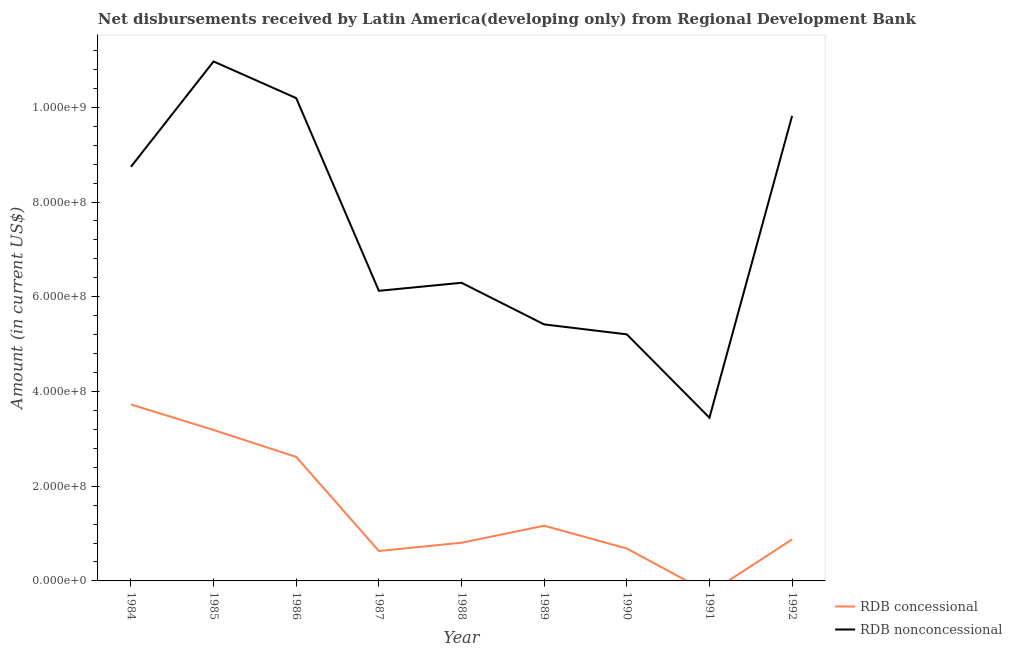Is the number of lines equal to the number of legend labels?
Offer a very short reply. No. Across all years, what is the maximum net non concessional disbursements from rdb?
Your answer should be very brief. 1.10e+09. What is the total net concessional disbursements from rdb in the graph?
Provide a succinct answer. 1.37e+09. What is the difference between the net concessional disbursements from rdb in 1985 and that in 1988?
Offer a very short reply. 2.38e+08. What is the difference between the net concessional disbursements from rdb in 1989 and the net non concessional disbursements from rdb in 1988?
Give a very brief answer. -5.13e+08. What is the average net non concessional disbursements from rdb per year?
Keep it short and to the point. 7.36e+08. In the year 1984, what is the difference between the net non concessional disbursements from rdb and net concessional disbursements from rdb?
Your response must be concise. 5.02e+08. In how many years, is the net concessional disbursements from rdb greater than 400000000 US$?
Your answer should be compact. 0. What is the ratio of the net concessional disbursements from rdb in 1987 to that in 1990?
Keep it short and to the point. 0.92. Is the net concessional disbursements from rdb in 1985 less than that in 1987?
Give a very brief answer. No. Is the difference between the net non concessional disbursements from rdb in 1988 and 1992 greater than the difference between the net concessional disbursements from rdb in 1988 and 1992?
Provide a succinct answer. No. What is the difference between the highest and the second highest net non concessional disbursements from rdb?
Make the answer very short. 7.74e+07. What is the difference between the highest and the lowest net concessional disbursements from rdb?
Ensure brevity in your answer.  3.73e+08. Is the net non concessional disbursements from rdb strictly less than the net concessional disbursements from rdb over the years?
Make the answer very short. No. What is the difference between two consecutive major ticks on the Y-axis?
Your answer should be compact. 2.00e+08. Does the graph contain any zero values?
Provide a succinct answer. Yes. Does the graph contain grids?
Make the answer very short. No. Where does the legend appear in the graph?
Provide a succinct answer. Bottom right. What is the title of the graph?
Your answer should be compact. Net disbursements received by Latin America(developing only) from Regional Development Bank. Does "Import" appear as one of the legend labels in the graph?
Your answer should be compact. No. What is the label or title of the X-axis?
Your answer should be very brief. Year. What is the Amount (in current US$) of RDB concessional in 1984?
Ensure brevity in your answer.  3.73e+08. What is the Amount (in current US$) of RDB nonconcessional in 1984?
Your answer should be compact. 8.74e+08. What is the Amount (in current US$) in RDB concessional in 1985?
Ensure brevity in your answer.  3.19e+08. What is the Amount (in current US$) of RDB nonconcessional in 1985?
Provide a short and direct response. 1.10e+09. What is the Amount (in current US$) of RDB concessional in 1986?
Give a very brief answer. 2.62e+08. What is the Amount (in current US$) in RDB nonconcessional in 1986?
Make the answer very short. 1.02e+09. What is the Amount (in current US$) in RDB concessional in 1987?
Make the answer very short. 6.32e+07. What is the Amount (in current US$) in RDB nonconcessional in 1987?
Offer a very short reply. 6.13e+08. What is the Amount (in current US$) of RDB concessional in 1988?
Your answer should be very brief. 8.06e+07. What is the Amount (in current US$) in RDB nonconcessional in 1988?
Offer a terse response. 6.30e+08. What is the Amount (in current US$) in RDB concessional in 1989?
Your answer should be very brief. 1.17e+08. What is the Amount (in current US$) in RDB nonconcessional in 1989?
Keep it short and to the point. 5.42e+08. What is the Amount (in current US$) of RDB concessional in 1990?
Keep it short and to the point. 6.85e+07. What is the Amount (in current US$) in RDB nonconcessional in 1990?
Make the answer very short. 5.21e+08. What is the Amount (in current US$) of RDB concessional in 1991?
Keep it short and to the point. 0. What is the Amount (in current US$) of RDB nonconcessional in 1991?
Your response must be concise. 3.45e+08. What is the Amount (in current US$) in RDB concessional in 1992?
Give a very brief answer. 8.76e+07. What is the Amount (in current US$) of RDB nonconcessional in 1992?
Your response must be concise. 9.82e+08. Across all years, what is the maximum Amount (in current US$) of RDB concessional?
Your answer should be compact. 3.73e+08. Across all years, what is the maximum Amount (in current US$) of RDB nonconcessional?
Provide a succinct answer. 1.10e+09. Across all years, what is the minimum Amount (in current US$) of RDB nonconcessional?
Ensure brevity in your answer.  3.45e+08. What is the total Amount (in current US$) of RDB concessional in the graph?
Offer a terse response. 1.37e+09. What is the total Amount (in current US$) in RDB nonconcessional in the graph?
Offer a very short reply. 6.62e+09. What is the difference between the Amount (in current US$) in RDB concessional in 1984 and that in 1985?
Make the answer very short. 5.39e+07. What is the difference between the Amount (in current US$) in RDB nonconcessional in 1984 and that in 1985?
Your response must be concise. -2.22e+08. What is the difference between the Amount (in current US$) of RDB concessional in 1984 and that in 1986?
Provide a succinct answer. 1.11e+08. What is the difference between the Amount (in current US$) in RDB nonconcessional in 1984 and that in 1986?
Keep it short and to the point. -1.45e+08. What is the difference between the Amount (in current US$) of RDB concessional in 1984 and that in 1987?
Keep it short and to the point. 3.09e+08. What is the difference between the Amount (in current US$) in RDB nonconcessional in 1984 and that in 1987?
Offer a terse response. 2.62e+08. What is the difference between the Amount (in current US$) in RDB concessional in 1984 and that in 1988?
Provide a succinct answer. 2.92e+08. What is the difference between the Amount (in current US$) in RDB nonconcessional in 1984 and that in 1988?
Give a very brief answer. 2.45e+08. What is the difference between the Amount (in current US$) in RDB concessional in 1984 and that in 1989?
Your answer should be very brief. 2.56e+08. What is the difference between the Amount (in current US$) of RDB nonconcessional in 1984 and that in 1989?
Offer a terse response. 3.33e+08. What is the difference between the Amount (in current US$) in RDB concessional in 1984 and that in 1990?
Offer a very short reply. 3.04e+08. What is the difference between the Amount (in current US$) in RDB nonconcessional in 1984 and that in 1990?
Ensure brevity in your answer.  3.54e+08. What is the difference between the Amount (in current US$) of RDB nonconcessional in 1984 and that in 1991?
Make the answer very short. 5.30e+08. What is the difference between the Amount (in current US$) of RDB concessional in 1984 and that in 1992?
Ensure brevity in your answer.  2.85e+08. What is the difference between the Amount (in current US$) of RDB nonconcessional in 1984 and that in 1992?
Provide a short and direct response. -1.08e+08. What is the difference between the Amount (in current US$) in RDB concessional in 1985 and that in 1986?
Make the answer very short. 5.69e+07. What is the difference between the Amount (in current US$) of RDB nonconcessional in 1985 and that in 1986?
Give a very brief answer. 7.74e+07. What is the difference between the Amount (in current US$) in RDB concessional in 1985 and that in 1987?
Provide a succinct answer. 2.56e+08. What is the difference between the Amount (in current US$) of RDB nonconcessional in 1985 and that in 1987?
Your response must be concise. 4.84e+08. What is the difference between the Amount (in current US$) of RDB concessional in 1985 and that in 1988?
Keep it short and to the point. 2.38e+08. What is the difference between the Amount (in current US$) in RDB nonconcessional in 1985 and that in 1988?
Make the answer very short. 4.67e+08. What is the difference between the Amount (in current US$) of RDB concessional in 1985 and that in 1989?
Offer a very short reply. 2.02e+08. What is the difference between the Amount (in current US$) in RDB nonconcessional in 1985 and that in 1989?
Provide a succinct answer. 5.55e+08. What is the difference between the Amount (in current US$) in RDB concessional in 1985 and that in 1990?
Offer a very short reply. 2.50e+08. What is the difference between the Amount (in current US$) of RDB nonconcessional in 1985 and that in 1990?
Ensure brevity in your answer.  5.76e+08. What is the difference between the Amount (in current US$) of RDB nonconcessional in 1985 and that in 1991?
Keep it short and to the point. 7.52e+08. What is the difference between the Amount (in current US$) of RDB concessional in 1985 and that in 1992?
Your answer should be very brief. 2.31e+08. What is the difference between the Amount (in current US$) of RDB nonconcessional in 1985 and that in 1992?
Ensure brevity in your answer.  1.15e+08. What is the difference between the Amount (in current US$) in RDB concessional in 1986 and that in 1987?
Provide a succinct answer. 1.99e+08. What is the difference between the Amount (in current US$) in RDB nonconcessional in 1986 and that in 1987?
Make the answer very short. 4.07e+08. What is the difference between the Amount (in current US$) of RDB concessional in 1986 and that in 1988?
Your answer should be compact. 1.81e+08. What is the difference between the Amount (in current US$) of RDB nonconcessional in 1986 and that in 1988?
Give a very brief answer. 3.90e+08. What is the difference between the Amount (in current US$) of RDB concessional in 1986 and that in 1989?
Your answer should be compact. 1.45e+08. What is the difference between the Amount (in current US$) of RDB nonconcessional in 1986 and that in 1989?
Provide a short and direct response. 4.78e+08. What is the difference between the Amount (in current US$) of RDB concessional in 1986 and that in 1990?
Provide a succinct answer. 1.93e+08. What is the difference between the Amount (in current US$) in RDB nonconcessional in 1986 and that in 1990?
Provide a short and direct response. 4.99e+08. What is the difference between the Amount (in current US$) in RDB nonconcessional in 1986 and that in 1991?
Provide a short and direct response. 6.75e+08. What is the difference between the Amount (in current US$) of RDB concessional in 1986 and that in 1992?
Offer a very short reply. 1.74e+08. What is the difference between the Amount (in current US$) in RDB nonconcessional in 1986 and that in 1992?
Provide a succinct answer. 3.75e+07. What is the difference between the Amount (in current US$) in RDB concessional in 1987 and that in 1988?
Your answer should be compact. -1.74e+07. What is the difference between the Amount (in current US$) of RDB nonconcessional in 1987 and that in 1988?
Your answer should be very brief. -1.70e+07. What is the difference between the Amount (in current US$) in RDB concessional in 1987 and that in 1989?
Ensure brevity in your answer.  -5.33e+07. What is the difference between the Amount (in current US$) in RDB nonconcessional in 1987 and that in 1989?
Your answer should be very brief. 7.09e+07. What is the difference between the Amount (in current US$) of RDB concessional in 1987 and that in 1990?
Offer a terse response. -5.23e+06. What is the difference between the Amount (in current US$) of RDB nonconcessional in 1987 and that in 1990?
Provide a succinct answer. 9.19e+07. What is the difference between the Amount (in current US$) in RDB nonconcessional in 1987 and that in 1991?
Ensure brevity in your answer.  2.68e+08. What is the difference between the Amount (in current US$) in RDB concessional in 1987 and that in 1992?
Give a very brief answer. -2.44e+07. What is the difference between the Amount (in current US$) in RDB nonconcessional in 1987 and that in 1992?
Make the answer very short. -3.69e+08. What is the difference between the Amount (in current US$) of RDB concessional in 1988 and that in 1989?
Give a very brief answer. -3.59e+07. What is the difference between the Amount (in current US$) of RDB nonconcessional in 1988 and that in 1989?
Your response must be concise. 8.79e+07. What is the difference between the Amount (in current US$) of RDB concessional in 1988 and that in 1990?
Provide a succinct answer. 1.22e+07. What is the difference between the Amount (in current US$) in RDB nonconcessional in 1988 and that in 1990?
Give a very brief answer. 1.09e+08. What is the difference between the Amount (in current US$) in RDB nonconcessional in 1988 and that in 1991?
Offer a very short reply. 2.85e+08. What is the difference between the Amount (in current US$) in RDB concessional in 1988 and that in 1992?
Provide a succinct answer. -7.02e+06. What is the difference between the Amount (in current US$) in RDB nonconcessional in 1988 and that in 1992?
Provide a short and direct response. -3.52e+08. What is the difference between the Amount (in current US$) of RDB concessional in 1989 and that in 1990?
Provide a short and direct response. 4.81e+07. What is the difference between the Amount (in current US$) in RDB nonconcessional in 1989 and that in 1990?
Provide a short and direct response. 2.10e+07. What is the difference between the Amount (in current US$) in RDB nonconcessional in 1989 and that in 1991?
Make the answer very short. 1.97e+08. What is the difference between the Amount (in current US$) of RDB concessional in 1989 and that in 1992?
Provide a succinct answer. 2.89e+07. What is the difference between the Amount (in current US$) of RDB nonconcessional in 1989 and that in 1992?
Provide a short and direct response. -4.40e+08. What is the difference between the Amount (in current US$) in RDB nonconcessional in 1990 and that in 1991?
Your answer should be very brief. 1.76e+08. What is the difference between the Amount (in current US$) of RDB concessional in 1990 and that in 1992?
Keep it short and to the point. -1.92e+07. What is the difference between the Amount (in current US$) in RDB nonconcessional in 1990 and that in 1992?
Provide a short and direct response. -4.61e+08. What is the difference between the Amount (in current US$) of RDB nonconcessional in 1991 and that in 1992?
Your answer should be very brief. -6.37e+08. What is the difference between the Amount (in current US$) of RDB concessional in 1984 and the Amount (in current US$) of RDB nonconcessional in 1985?
Keep it short and to the point. -7.24e+08. What is the difference between the Amount (in current US$) in RDB concessional in 1984 and the Amount (in current US$) in RDB nonconcessional in 1986?
Provide a short and direct response. -6.47e+08. What is the difference between the Amount (in current US$) of RDB concessional in 1984 and the Amount (in current US$) of RDB nonconcessional in 1987?
Provide a short and direct response. -2.40e+08. What is the difference between the Amount (in current US$) in RDB concessional in 1984 and the Amount (in current US$) in RDB nonconcessional in 1988?
Give a very brief answer. -2.57e+08. What is the difference between the Amount (in current US$) in RDB concessional in 1984 and the Amount (in current US$) in RDB nonconcessional in 1989?
Keep it short and to the point. -1.69e+08. What is the difference between the Amount (in current US$) in RDB concessional in 1984 and the Amount (in current US$) in RDB nonconcessional in 1990?
Offer a terse response. -1.48e+08. What is the difference between the Amount (in current US$) in RDB concessional in 1984 and the Amount (in current US$) in RDB nonconcessional in 1991?
Ensure brevity in your answer.  2.80e+07. What is the difference between the Amount (in current US$) of RDB concessional in 1984 and the Amount (in current US$) of RDB nonconcessional in 1992?
Provide a short and direct response. -6.09e+08. What is the difference between the Amount (in current US$) of RDB concessional in 1985 and the Amount (in current US$) of RDB nonconcessional in 1986?
Provide a succinct answer. -7.01e+08. What is the difference between the Amount (in current US$) of RDB concessional in 1985 and the Amount (in current US$) of RDB nonconcessional in 1987?
Give a very brief answer. -2.94e+08. What is the difference between the Amount (in current US$) of RDB concessional in 1985 and the Amount (in current US$) of RDB nonconcessional in 1988?
Give a very brief answer. -3.11e+08. What is the difference between the Amount (in current US$) of RDB concessional in 1985 and the Amount (in current US$) of RDB nonconcessional in 1989?
Offer a very short reply. -2.23e+08. What is the difference between the Amount (in current US$) in RDB concessional in 1985 and the Amount (in current US$) in RDB nonconcessional in 1990?
Keep it short and to the point. -2.02e+08. What is the difference between the Amount (in current US$) of RDB concessional in 1985 and the Amount (in current US$) of RDB nonconcessional in 1991?
Offer a terse response. -2.59e+07. What is the difference between the Amount (in current US$) in RDB concessional in 1985 and the Amount (in current US$) in RDB nonconcessional in 1992?
Offer a terse response. -6.63e+08. What is the difference between the Amount (in current US$) of RDB concessional in 1986 and the Amount (in current US$) of RDB nonconcessional in 1987?
Offer a terse response. -3.51e+08. What is the difference between the Amount (in current US$) in RDB concessional in 1986 and the Amount (in current US$) in RDB nonconcessional in 1988?
Make the answer very short. -3.68e+08. What is the difference between the Amount (in current US$) of RDB concessional in 1986 and the Amount (in current US$) of RDB nonconcessional in 1989?
Your answer should be very brief. -2.80e+08. What is the difference between the Amount (in current US$) of RDB concessional in 1986 and the Amount (in current US$) of RDB nonconcessional in 1990?
Make the answer very short. -2.59e+08. What is the difference between the Amount (in current US$) of RDB concessional in 1986 and the Amount (in current US$) of RDB nonconcessional in 1991?
Offer a terse response. -8.29e+07. What is the difference between the Amount (in current US$) in RDB concessional in 1986 and the Amount (in current US$) in RDB nonconcessional in 1992?
Ensure brevity in your answer.  -7.20e+08. What is the difference between the Amount (in current US$) of RDB concessional in 1987 and the Amount (in current US$) of RDB nonconcessional in 1988?
Make the answer very short. -5.66e+08. What is the difference between the Amount (in current US$) in RDB concessional in 1987 and the Amount (in current US$) in RDB nonconcessional in 1989?
Your response must be concise. -4.78e+08. What is the difference between the Amount (in current US$) in RDB concessional in 1987 and the Amount (in current US$) in RDB nonconcessional in 1990?
Provide a short and direct response. -4.57e+08. What is the difference between the Amount (in current US$) in RDB concessional in 1987 and the Amount (in current US$) in RDB nonconcessional in 1991?
Your response must be concise. -2.81e+08. What is the difference between the Amount (in current US$) in RDB concessional in 1987 and the Amount (in current US$) in RDB nonconcessional in 1992?
Your answer should be very brief. -9.19e+08. What is the difference between the Amount (in current US$) of RDB concessional in 1988 and the Amount (in current US$) of RDB nonconcessional in 1989?
Offer a terse response. -4.61e+08. What is the difference between the Amount (in current US$) of RDB concessional in 1988 and the Amount (in current US$) of RDB nonconcessional in 1990?
Give a very brief answer. -4.40e+08. What is the difference between the Amount (in current US$) of RDB concessional in 1988 and the Amount (in current US$) of RDB nonconcessional in 1991?
Offer a terse response. -2.64e+08. What is the difference between the Amount (in current US$) in RDB concessional in 1988 and the Amount (in current US$) in RDB nonconcessional in 1992?
Provide a succinct answer. -9.01e+08. What is the difference between the Amount (in current US$) of RDB concessional in 1989 and the Amount (in current US$) of RDB nonconcessional in 1990?
Your response must be concise. -4.04e+08. What is the difference between the Amount (in current US$) of RDB concessional in 1989 and the Amount (in current US$) of RDB nonconcessional in 1991?
Give a very brief answer. -2.28e+08. What is the difference between the Amount (in current US$) in RDB concessional in 1989 and the Amount (in current US$) in RDB nonconcessional in 1992?
Your answer should be compact. -8.65e+08. What is the difference between the Amount (in current US$) of RDB concessional in 1990 and the Amount (in current US$) of RDB nonconcessional in 1991?
Provide a short and direct response. -2.76e+08. What is the difference between the Amount (in current US$) in RDB concessional in 1990 and the Amount (in current US$) in RDB nonconcessional in 1992?
Ensure brevity in your answer.  -9.14e+08. What is the average Amount (in current US$) in RDB concessional per year?
Your answer should be very brief. 1.52e+08. What is the average Amount (in current US$) in RDB nonconcessional per year?
Your response must be concise. 7.36e+08. In the year 1984, what is the difference between the Amount (in current US$) in RDB concessional and Amount (in current US$) in RDB nonconcessional?
Your response must be concise. -5.02e+08. In the year 1985, what is the difference between the Amount (in current US$) in RDB concessional and Amount (in current US$) in RDB nonconcessional?
Give a very brief answer. -7.78e+08. In the year 1986, what is the difference between the Amount (in current US$) of RDB concessional and Amount (in current US$) of RDB nonconcessional?
Make the answer very short. -7.58e+08. In the year 1987, what is the difference between the Amount (in current US$) in RDB concessional and Amount (in current US$) in RDB nonconcessional?
Ensure brevity in your answer.  -5.49e+08. In the year 1988, what is the difference between the Amount (in current US$) in RDB concessional and Amount (in current US$) in RDB nonconcessional?
Keep it short and to the point. -5.49e+08. In the year 1989, what is the difference between the Amount (in current US$) in RDB concessional and Amount (in current US$) in RDB nonconcessional?
Give a very brief answer. -4.25e+08. In the year 1990, what is the difference between the Amount (in current US$) in RDB concessional and Amount (in current US$) in RDB nonconcessional?
Provide a succinct answer. -4.52e+08. In the year 1992, what is the difference between the Amount (in current US$) in RDB concessional and Amount (in current US$) in RDB nonconcessional?
Make the answer very short. -8.94e+08. What is the ratio of the Amount (in current US$) of RDB concessional in 1984 to that in 1985?
Provide a short and direct response. 1.17. What is the ratio of the Amount (in current US$) in RDB nonconcessional in 1984 to that in 1985?
Your answer should be very brief. 0.8. What is the ratio of the Amount (in current US$) in RDB concessional in 1984 to that in 1986?
Keep it short and to the point. 1.42. What is the ratio of the Amount (in current US$) of RDB nonconcessional in 1984 to that in 1986?
Provide a succinct answer. 0.86. What is the ratio of the Amount (in current US$) of RDB concessional in 1984 to that in 1987?
Your response must be concise. 5.89. What is the ratio of the Amount (in current US$) of RDB nonconcessional in 1984 to that in 1987?
Give a very brief answer. 1.43. What is the ratio of the Amount (in current US$) in RDB concessional in 1984 to that in 1988?
Provide a succinct answer. 4.62. What is the ratio of the Amount (in current US$) of RDB nonconcessional in 1984 to that in 1988?
Provide a short and direct response. 1.39. What is the ratio of the Amount (in current US$) in RDB concessional in 1984 to that in 1989?
Offer a very short reply. 3.2. What is the ratio of the Amount (in current US$) in RDB nonconcessional in 1984 to that in 1989?
Make the answer very short. 1.61. What is the ratio of the Amount (in current US$) in RDB concessional in 1984 to that in 1990?
Your answer should be very brief. 5.44. What is the ratio of the Amount (in current US$) of RDB nonconcessional in 1984 to that in 1990?
Ensure brevity in your answer.  1.68. What is the ratio of the Amount (in current US$) in RDB nonconcessional in 1984 to that in 1991?
Provide a short and direct response. 2.54. What is the ratio of the Amount (in current US$) of RDB concessional in 1984 to that in 1992?
Keep it short and to the point. 4.25. What is the ratio of the Amount (in current US$) of RDB nonconcessional in 1984 to that in 1992?
Make the answer very short. 0.89. What is the ratio of the Amount (in current US$) in RDB concessional in 1985 to that in 1986?
Offer a very short reply. 1.22. What is the ratio of the Amount (in current US$) of RDB nonconcessional in 1985 to that in 1986?
Provide a succinct answer. 1.08. What is the ratio of the Amount (in current US$) of RDB concessional in 1985 to that in 1987?
Make the answer very short. 5.04. What is the ratio of the Amount (in current US$) of RDB nonconcessional in 1985 to that in 1987?
Your response must be concise. 1.79. What is the ratio of the Amount (in current US$) of RDB concessional in 1985 to that in 1988?
Provide a succinct answer. 3.95. What is the ratio of the Amount (in current US$) in RDB nonconcessional in 1985 to that in 1988?
Make the answer very short. 1.74. What is the ratio of the Amount (in current US$) in RDB concessional in 1985 to that in 1989?
Offer a very short reply. 2.73. What is the ratio of the Amount (in current US$) of RDB nonconcessional in 1985 to that in 1989?
Your response must be concise. 2.03. What is the ratio of the Amount (in current US$) of RDB concessional in 1985 to that in 1990?
Provide a short and direct response. 4.66. What is the ratio of the Amount (in current US$) in RDB nonconcessional in 1985 to that in 1990?
Give a very brief answer. 2.11. What is the ratio of the Amount (in current US$) of RDB nonconcessional in 1985 to that in 1991?
Your response must be concise. 3.18. What is the ratio of the Amount (in current US$) of RDB concessional in 1985 to that in 1992?
Make the answer very short. 3.64. What is the ratio of the Amount (in current US$) in RDB nonconcessional in 1985 to that in 1992?
Give a very brief answer. 1.12. What is the ratio of the Amount (in current US$) of RDB concessional in 1986 to that in 1987?
Keep it short and to the point. 4.14. What is the ratio of the Amount (in current US$) of RDB nonconcessional in 1986 to that in 1987?
Give a very brief answer. 1.66. What is the ratio of the Amount (in current US$) of RDB concessional in 1986 to that in 1988?
Your response must be concise. 3.25. What is the ratio of the Amount (in current US$) in RDB nonconcessional in 1986 to that in 1988?
Provide a short and direct response. 1.62. What is the ratio of the Amount (in current US$) in RDB concessional in 1986 to that in 1989?
Keep it short and to the point. 2.25. What is the ratio of the Amount (in current US$) of RDB nonconcessional in 1986 to that in 1989?
Offer a very short reply. 1.88. What is the ratio of the Amount (in current US$) of RDB concessional in 1986 to that in 1990?
Offer a terse response. 3.82. What is the ratio of the Amount (in current US$) in RDB nonconcessional in 1986 to that in 1990?
Give a very brief answer. 1.96. What is the ratio of the Amount (in current US$) of RDB nonconcessional in 1986 to that in 1991?
Your answer should be compact. 2.96. What is the ratio of the Amount (in current US$) of RDB concessional in 1986 to that in 1992?
Your response must be concise. 2.99. What is the ratio of the Amount (in current US$) of RDB nonconcessional in 1986 to that in 1992?
Provide a short and direct response. 1.04. What is the ratio of the Amount (in current US$) of RDB concessional in 1987 to that in 1988?
Offer a terse response. 0.78. What is the ratio of the Amount (in current US$) of RDB concessional in 1987 to that in 1989?
Offer a very short reply. 0.54. What is the ratio of the Amount (in current US$) of RDB nonconcessional in 1987 to that in 1989?
Provide a short and direct response. 1.13. What is the ratio of the Amount (in current US$) in RDB concessional in 1987 to that in 1990?
Offer a terse response. 0.92. What is the ratio of the Amount (in current US$) in RDB nonconcessional in 1987 to that in 1990?
Offer a terse response. 1.18. What is the ratio of the Amount (in current US$) in RDB nonconcessional in 1987 to that in 1991?
Ensure brevity in your answer.  1.78. What is the ratio of the Amount (in current US$) in RDB concessional in 1987 to that in 1992?
Provide a short and direct response. 0.72. What is the ratio of the Amount (in current US$) in RDB nonconcessional in 1987 to that in 1992?
Your answer should be compact. 0.62. What is the ratio of the Amount (in current US$) in RDB concessional in 1988 to that in 1989?
Offer a very short reply. 0.69. What is the ratio of the Amount (in current US$) of RDB nonconcessional in 1988 to that in 1989?
Offer a terse response. 1.16. What is the ratio of the Amount (in current US$) of RDB concessional in 1988 to that in 1990?
Provide a succinct answer. 1.18. What is the ratio of the Amount (in current US$) in RDB nonconcessional in 1988 to that in 1990?
Keep it short and to the point. 1.21. What is the ratio of the Amount (in current US$) in RDB nonconcessional in 1988 to that in 1991?
Keep it short and to the point. 1.83. What is the ratio of the Amount (in current US$) of RDB concessional in 1988 to that in 1992?
Your answer should be compact. 0.92. What is the ratio of the Amount (in current US$) of RDB nonconcessional in 1988 to that in 1992?
Provide a short and direct response. 0.64. What is the ratio of the Amount (in current US$) in RDB concessional in 1989 to that in 1990?
Your response must be concise. 1.7. What is the ratio of the Amount (in current US$) in RDB nonconcessional in 1989 to that in 1990?
Give a very brief answer. 1.04. What is the ratio of the Amount (in current US$) in RDB nonconcessional in 1989 to that in 1991?
Offer a very short reply. 1.57. What is the ratio of the Amount (in current US$) in RDB concessional in 1989 to that in 1992?
Offer a very short reply. 1.33. What is the ratio of the Amount (in current US$) in RDB nonconcessional in 1989 to that in 1992?
Offer a terse response. 0.55. What is the ratio of the Amount (in current US$) of RDB nonconcessional in 1990 to that in 1991?
Provide a short and direct response. 1.51. What is the ratio of the Amount (in current US$) in RDB concessional in 1990 to that in 1992?
Provide a succinct answer. 0.78. What is the ratio of the Amount (in current US$) of RDB nonconcessional in 1990 to that in 1992?
Give a very brief answer. 0.53. What is the ratio of the Amount (in current US$) in RDB nonconcessional in 1991 to that in 1992?
Keep it short and to the point. 0.35. What is the difference between the highest and the second highest Amount (in current US$) in RDB concessional?
Keep it short and to the point. 5.39e+07. What is the difference between the highest and the second highest Amount (in current US$) of RDB nonconcessional?
Keep it short and to the point. 7.74e+07. What is the difference between the highest and the lowest Amount (in current US$) of RDB concessional?
Your answer should be compact. 3.73e+08. What is the difference between the highest and the lowest Amount (in current US$) of RDB nonconcessional?
Your answer should be very brief. 7.52e+08. 